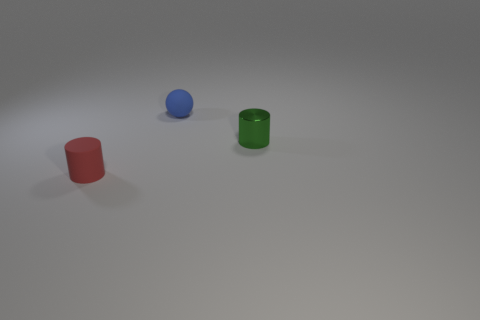Can you describe the colors of the objects and the order they appear in from left to right? From left to right, the objects are a red matte cylinder, a blue matte ball, and a green matte cylinder. 